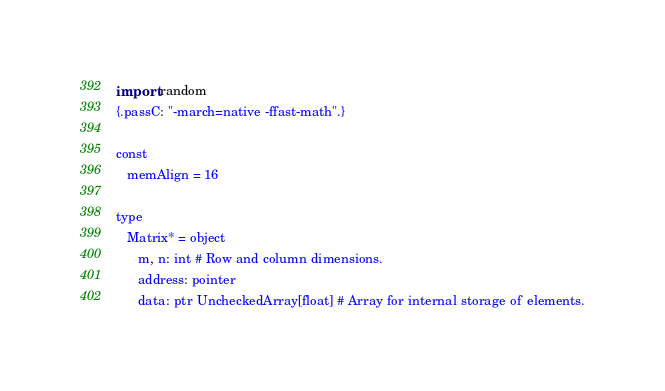Convert code to text. <code><loc_0><loc_0><loc_500><loc_500><_Nim_>import random
{.passC: "-march=native -ffast-math".}

const
   memAlign = 16

type
   Matrix* = object
      m, n: int # Row and column dimensions.
      address: pointer
      data: ptr UncheckedArray[float] # Array for internal storage of elements.
</code> 